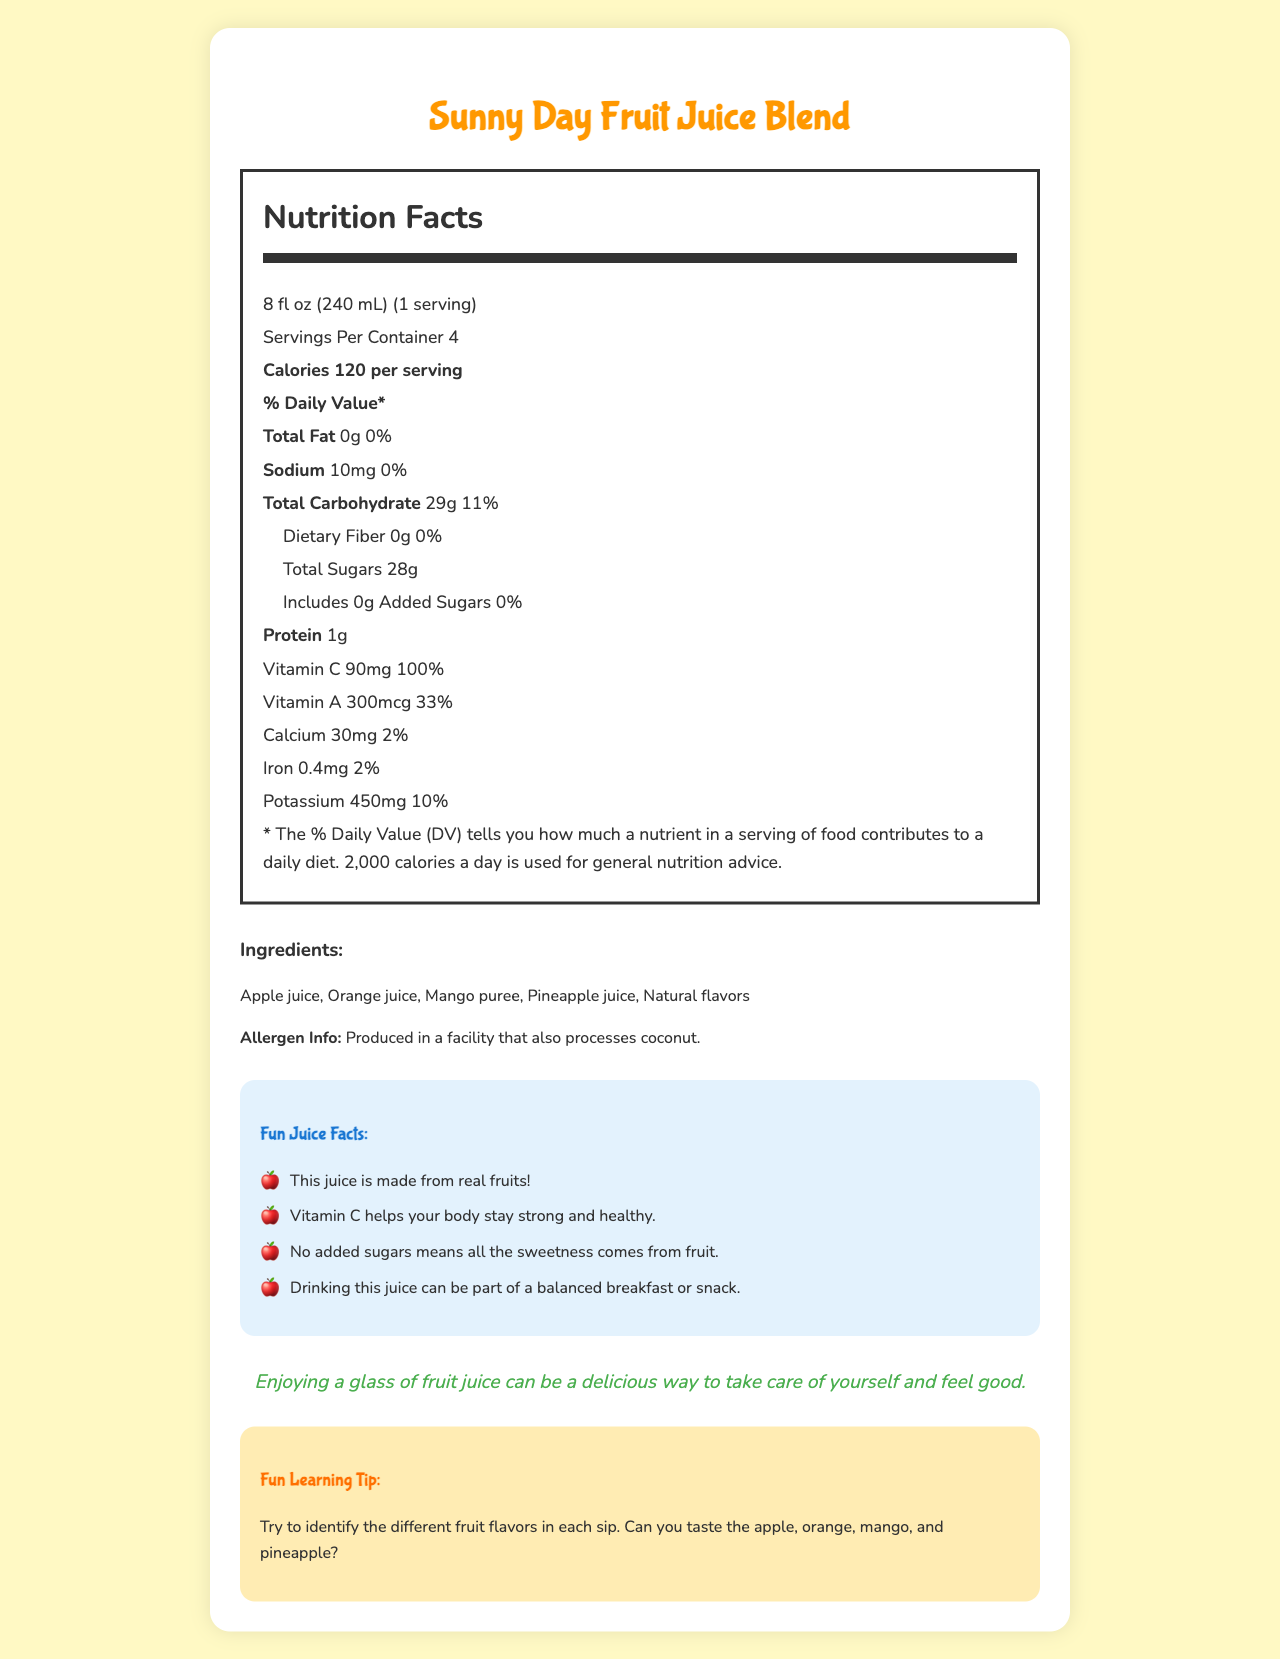what is the serving size for Sunny Day Fruit Juice Blend? The serving size is directly mentioned in the Nutrition Facts section of the document.
Answer: 8 fl oz (240 mL) how many calories are there per serving? The Nutrition Facts label states that each serving contains 120 calories.
Answer: 120 what are the ingredients in Sunny Day Fruit Juice Blend? The ingredients are listed under the Ingredients section in the document.
Answer: Apple juice, Orange juice, Mango puree, Pineapple juice, Natural flavors how much vitamin C does one serving provide? The amount of vitamin C per serving is listed in the Nutrition Facts section.
Answer: 90mg what is the daily value percentage of vitamin C per serving? The document lists the daily value for vitamin C as 100%.
Answer: 100% how many servings are in the container? The Nutrition Facts label mentions that there are 4 servings per container.
Answer: 4 what is the total carbohydrate content per serving? A. 11g B. 29g C. 10mg D. 120mg The Nutrition Facts label shows that the total carbohydrate content per serving is 29g.
Answer: B what is the sodium content per serving? A. 5mg B. 10mg C. 0mg D. 2% The Nutrition Facts label specifies that the sodium content per serving is 10mg.
Answer: B are there any added sugars in the juice? The Nutrition Facts label indicates that there are 0g of added sugars in the juice.
Answer: No is the product made in a facility that processes allergens? The document clearly states that the juice is produced in a facility that also processes coconut.
Answer: Yes summarize the main idea of the document. The document primarily provides nutritional information and ingredients of Sunny Day Fruit Juice Blend, emphasizing its health benefits and suitability as part of a balanced diet for kids.
Answer: Sunny Day Fruit Juice Blend is a natural fruit juice blend with no added sugars, providing essential nutrients like 100% daily value of vitamin C per serving. It consists of real fruit ingredients and is intended to be a healthy option for kids. how much protein is in each serving? The Nutrition Facts label lists the protein content as 1g per serving.
Answer: 1g does the juice contain any dietary fiber? The Nutrition Facts section shows 0g of dietary fiber per serving.
Answer: No what is one comforting message mentioned in the document? This message is found in the Comforting Message section.
Answer: Enjoying a glass of fruit juice can be a delicious way to take care of yourself and feel good. how much potassium is there per serving? The Nutrition Facts label indicates that each serving contains 450mg of potassium.
Answer: 450mg how is the juice best enjoyed according to the document? The Fun Juice Facts section suggests that drinking the juice can be part of a balanced breakfast or snack.
Answer: As part of a balanced breakfast or snack does the juice contain any vitamin A? The Nutrition Facts label indicates that the juice contains 300mcg of vitamin A per serving which is 33% daily value.
Answer: Yes what is the main source of sweetness in this juice? Stated in the Fun Juice Facts that it has no added sugars and the sweetness comes naturally from the fruits.
Answer: The sweetness comes from fruit, as there are no added sugars. 